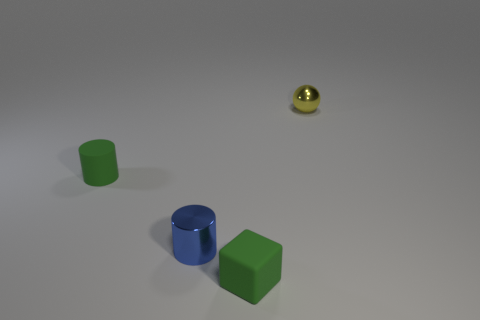Can you guess the possible setting of this scene or what these objects might be used for? The setting appears to be a neutral, nondescript space with a plain background, likely constructed for the purpose of displaying or analyzing these objects without external context. These items might be used for educational demonstrations, like teaching geometry or material properties, or they could be part of a visual composition exercise in an artistic or design setting. Could these objects represent something larger, perhaps a metaphorical meaning? Indeed, in an abstract sense, these objects could symbolize various themes. The different shapes might represent diversity or various elements coming together. The distinct materials could suggest a mix of textures and characteristics in life or art. And the relative sizes might illustrate concepts of scale or significance. Figures in a metaphor can be open-ended and interpreted in myriad ways depending on the viewer's perspective. 